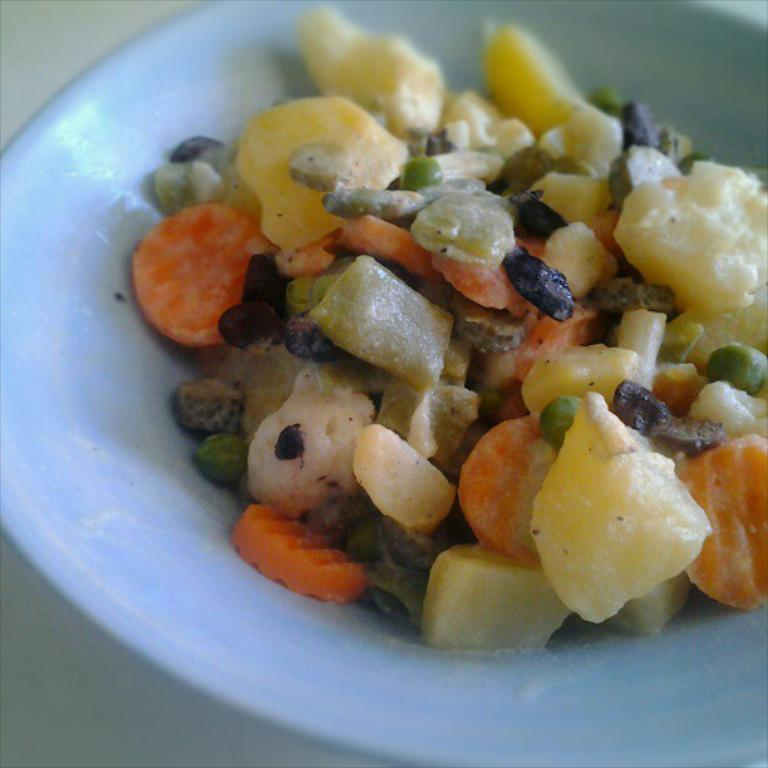What is on the plate in the image? The plate contains a salad. What types of vegetables are included in the salad? The salad includes vegetables such as carrots, peas, and potatoes. Are there any other food items in the salad? Yes, there are other food items in the salad. What type of teeth can be seen in the image? There are no teeth visible in the image, as it features a plate with a salad and no living organisms with teeth are present. 